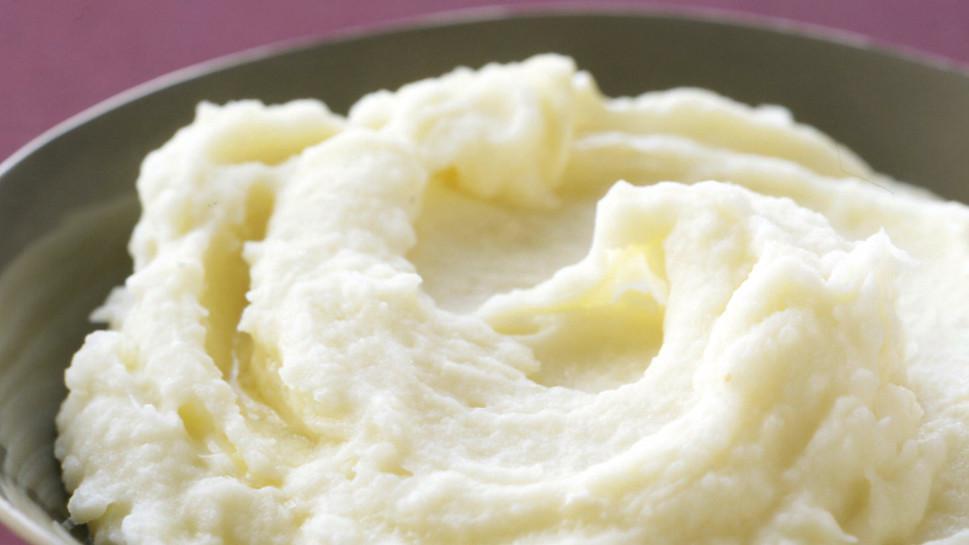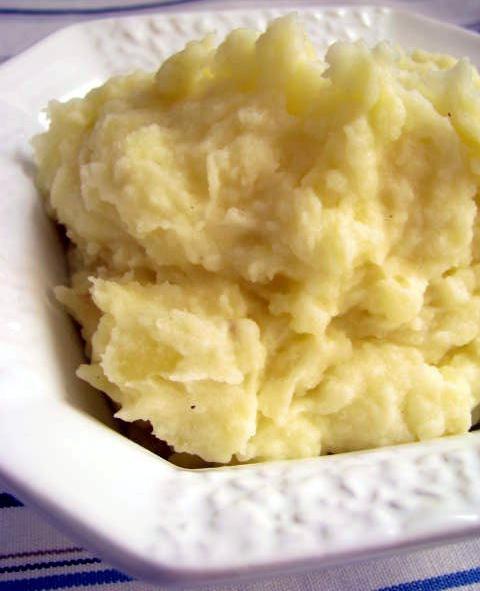The first image is the image on the left, the second image is the image on the right. For the images displayed, is the sentence "One of the mashed potato dishes is squared, with four sides." factually correct? Answer yes or no. No. 